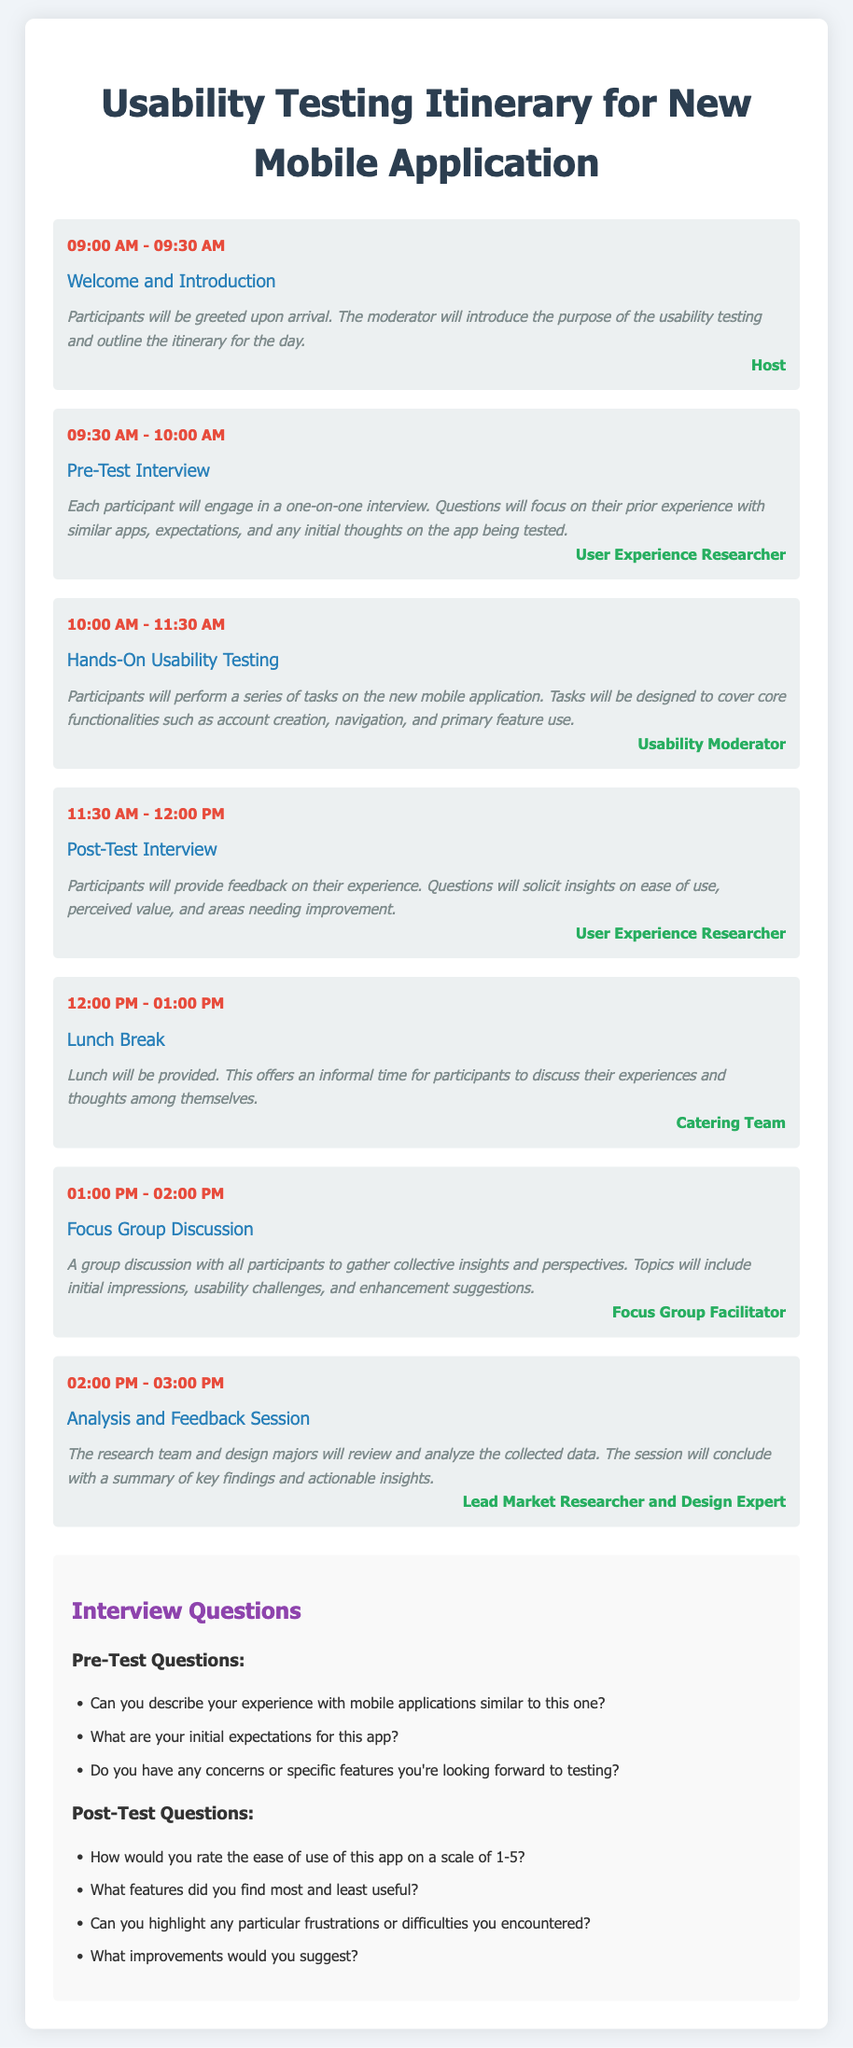What time does the usability testing start? The itinerary specifies that the usability testing starts at 10:00 AM.
Answer: 10:00 AM Who is responsible for the focus group discussion? The itinerary indicates that the Focus Group Facilitator is responsible for the focus group discussion.
Answer: Focus Group Facilitator What is the duration of the lunch break? According to the document, the lunch break lasts for 1 hour.
Answer: 1 hour How many post-test interview questions are listed? The document includes four post-test questions listed under the post-test section.
Answer: 4 What activity is scheduled right after the pre-test interview? The next activity after the pre-test interview is the hands-on usability testing.
Answer: Hands-On Usability Testing What are participants asked about during the pre-test interview? Participants are asked about their prior experience with similar apps, expectations, and initial thoughts on the app.
Answer: Prior experience, expectations, initial thoughts What is the main purpose of the analysis and feedback session? The main purpose is to review and analyze the collected data and summarize key findings and actionable insights.
Answer: Review and analyze collected data What time does the post-test interview begin? The post-test interview starts at 11:30 AM.
Answer: 11:30 AM 